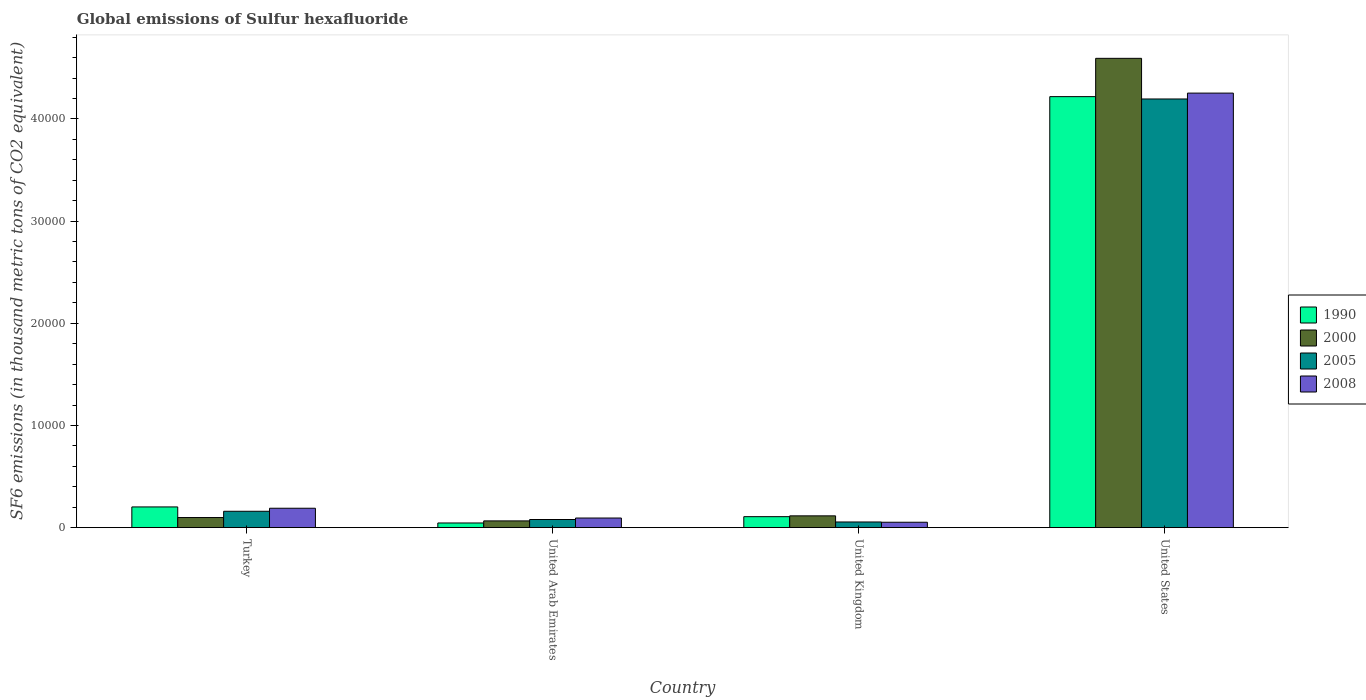How many different coloured bars are there?
Your response must be concise. 4. How many groups of bars are there?
Your answer should be compact. 4. Are the number of bars per tick equal to the number of legend labels?
Your response must be concise. Yes. How many bars are there on the 4th tick from the left?
Your answer should be very brief. 4. What is the label of the 1st group of bars from the left?
Provide a succinct answer. Turkey. What is the global emissions of Sulfur hexafluoride in 1990 in Turkey?
Make the answer very short. 2027.1. Across all countries, what is the maximum global emissions of Sulfur hexafluoride in 2000?
Your response must be concise. 4.59e+04. Across all countries, what is the minimum global emissions of Sulfur hexafluoride in 2008?
Offer a very short reply. 528.9. In which country was the global emissions of Sulfur hexafluoride in 2005 minimum?
Offer a very short reply. United Kingdom. What is the total global emissions of Sulfur hexafluoride in 2008 in the graph?
Offer a terse response. 4.59e+04. What is the difference between the global emissions of Sulfur hexafluoride in 2008 in Turkey and that in United Arab Emirates?
Offer a terse response. 957.4. What is the difference between the global emissions of Sulfur hexafluoride in 2005 in United Arab Emirates and the global emissions of Sulfur hexafluoride in 2008 in Turkey?
Your response must be concise. -1102.6. What is the average global emissions of Sulfur hexafluoride in 1990 per country?
Your answer should be very brief. 1.14e+04. What is the difference between the global emissions of Sulfur hexafluoride of/in 2008 and global emissions of Sulfur hexafluoride of/in 2000 in United States?
Offer a terse response. -3401.5. In how many countries, is the global emissions of Sulfur hexafluoride in 1990 greater than 4000 thousand metric tons?
Offer a terse response. 1. What is the ratio of the global emissions of Sulfur hexafluoride in 1990 in Turkey to that in United States?
Provide a succinct answer. 0.05. Is the global emissions of Sulfur hexafluoride in 2005 in Turkey less than that in United Kingdom?
Your response must be concise. No. What is the difference between the highest and the second highest global emissions of Sulfur hexafluoride in 2000?
Your answer should be compact. 4.49e+04. What is the difference between the highest and the lowest global emissions of Sulfur hexafluoride in 2005?
Offer a very short reply. 4.14e+04. In how many countries, is the global emissions of Sulfur hexafluoride in 1990 greater than the average global emissions of Sulfur hexafluoride in 1990 taken over all countries?
Provide a short and direct response. 1. What does the 4th bar from the left in Turkey represents?
Keep it short and to the point. 2008. What does the 2nd bar from the right in United States represents?
Make the answer very short. 2005. Is it the case that in every country, the sum of the global emissions of Sulfur hexafluoride in 2008 and global emissions of Sulfur hexafluoride in 2005 is greater than the global emissions of Sulfur hexafluoride in 1990?
Offer a terse response. Yes. Are all the bars in the graph horizontal?
Keep it short and to the point. No. How many countries are there in the graph?
Keep it short and to the point. 4. What is the difference between two consecutive major ticks on the Y-axis?
Provide a succinct answer. 10000. Does the graph contain any zero values?
Your answer should be compact. No. Does the graph contain grids?
Give a very brief answer. No. Where does the legend appear in the graph?
Offer a very short reply. Center right. What is the title of the graph?
Your answer should be very brief. Global emissions of Sulfur hexafluoride. What is the label or title of the X-axis?
Your response must be concise. Country. What is the label or title of the Y-axis?
Give a very brief answer. SF6 emissions (in thousand metric tons of CO2 equivalent). What is the SF6 emissions (in thousand metric tons of CO2 equivalent) of 1990 in Turkey?
Provide a succinct answer. 2027.1. What is the SF6 emissions (in thousand metric tons of CO2 equivalent) in 2000 in Turkey?
Your answer should be very brief. 989.2. What is the SF6 emissions (in thousand metric tons of CO2 equivalent) of 2005 in Turkey?
Keep it short and to the point. 1602.2. What is the SF6 emissions (in thousand metric tons of CO2 equivalent) of 2008 in Turkey?
Your answer should be very brief. 1898.8. What is the SF6 emissions (in thousand metric tons of CO2 equivalent) of 1990 in United Arab Emirates?
Provide a succinct answer. 456.1. What is the SF6 emissions (in thousand metric tons of CO2 equivalent) in 2000 in United Arab Emirates?
Offer a terse response. 660.1. What is the SF6 emissions (in thousand metric tons of CO2 equivalent) in 2005 in United Arab Emirates?
Keep it short and to the point. 796.2. What is the SF6 emissions (in thousand metric tons of CO2 equivalent) in 2008 in United Arab Emirates?
Provide a short and direct response. 941.4. What is the SF6 emissions (in thousand metric tons of CO2 equivalent) of 1990 in United Kingdom?
Your answer should be very brief. 1073.9. What is the SF6 emissions (in thousand metric tons of CO2 equivalent) in 2000 in United Kingdom?
Provide a short and direct response. 1154.1. What is the SF6 emissions (in thousand metric tons of CO2 equivalent) in 2005 in United Kingdom?
Make the answer very short. 554.2. What is the SF6 emissions (in thousand metric tons of CO2 equivalent) of 2008 in United Kingdom?
Give a very brief answer. 528.9. What is the SF6 emissions (in thousand metric tons of CO2 equivalent) of 1990 in United States?
Provide a succinct answer. 4.22e+04. What is the SF6 emissions (in thousand metric tons of CO2 equivalent) of 2000 in United States?
Your answer should be very brief. 4.59e+04. What is the SF6 emissions (in thousand metric tons of CO2 equivalent) of 2005 in United States?
Your answer should be compact. 4.20e+04. What is the SF6 emissions (in thousand metric tons of CO2 equivalent) in 2008 in United States?
Your response must be concise. 4.25e+04. Across all countries, what is the maximum SF6 emissions (in thousand metric tons of CO2 equivalent) in 1990?
Ensure brevity in your answer.  4.22e+04. Across all countries, what is the maximum SF6 emissions (in thousand metric tons of CO2 equivalent) of 2000?
Your answer should be very brief. 4.59e+04. Across all countries, what is the maximum SF6 emissions (in thousand metric tons of CO2 equivalent) of 2005?
Provide a succinct answer. 4.20e+04. Across all countries, what is the maximum SF6 emissions (in thousand metric tons of CO2 equivalent) of 2008?
Your response must be concise. 4.25e+04. Across all countries, what is the minimum SF6 emissions (in thousand metric tons of CO2 equivalent) of 1990?
Offer a very short reply. 456.1. Across all countries, what is the minimum SF6 emissions (in thousand metric tons of CO2 equivalent) of 2000?
Ensure brevity in your answer.  660.1. Across all countries, what is the minimum SF6 emissions (in thousand metric tons of CO2 equivalent) in 2005?
Offer a terse response. 554.2. Across all countries, what is the minimum SF6 emissions (in thousand metric tons of CO2 equivalent) of 2008?
Ensure brevity in your answer.  528.9. What is the total SF6 emissions (in thousand metric tons of CO2 equivalent) of 1990 in the graph?
Keep it short and to the point. 4.57e+04. What is the total SF6 emissions (in thousand metric tons of CO2 equivalent) of 2000 in the graph?
Keep it short and to the point. 4.87e+04. What is the total SF6 emissions (in thousand metric tons of CO2 equivalent) of 2005 in the graph?
Keep it short and to the point. 4.49e+04. What is the total SF6 emissions (in thousand metric tons of CO2 equivalent) in 2008 in the graph?
Ensure brevity in your answer.  4.59e+04. What is the difference between the SF6 emissions (in thousand metric tons of CO2 equivalent) in 1990 in Turkey and that in United Arab Emirates?
Provide a short and direct response. 1571. What is the difference between the SF6 emissions (in thousand metric tons of CO2 equivalent) in 2000 in Turkey and that in United Arab Emirates?
Provide a short and direct response. 329.1. What is the difference between the SF6 emissions (in thousand metric tons of CO2 equivalent) of 2005 in Turkey and that in United Arab Emirates?
Your answer should be very brief. 806. What is the difference between the SF6 emissions (in thousand metric tons of CO2 equivalent) of 2008 in Turkey and that in United Arab Emirates?
Ensure brevity in your answer.  957.4. What is the difference between the SF6 emissions (in thousand metric tons of CO2 equivalent) in 1990 in Turkey and that in United Kingdom?
Offer a terse response. 953.2. What is the difference between the SF6 emissions (in thousand metric tons of CO2 equivalent) in 2000 in Turkey and that in United Kingdom?
Offer a very short reply. -164.9. What is the difference between the SF6 emissions (in thousand metric tons of CO2 equivalent) of 2005 in Turkey and that in United Kingdom?
Provide a succinct answer. 1048. What is the difference between the SF6 emissions (in thousand metric tons of CO2 equivalent) in 2008 in Turkey and that in United Kingdom?
Keep it short and to the point. 1369.9. What is the difference between the SF6 emissions (in thousand metric tons of CO2 equivalent) in 1990 in Turkey and that in United States?
Provide a short and direct response. -4.02e+04. What is the difference between the SF6 emissions (in thousand metric tons of CO2 equivalent) of 2000 in Turkey and that in United States?
Keep it short and to the point. -4.49e+04. What is the difference between the SF6 emissions (in thousand metric tons of CO2 equivalent) in 2005 in Turkey and that in United States?
Make the answer very short. -4.04e+04. What is the difference between the SF6 emissions (in thousand metric tons of CO2 equivalent) in 2008 in Turkey and that in United States?
Your answer should be compact. -4.06e+04. What is the difference between the SF6 emissions (in thousand metric tons of CO2 equivalent) of 1990 in United Arab Emirates and that in United Kingdom?
Provide a succinct answer. -617.8. What is the difference between the SF6 emissions (in thousand metric tons of CO2 equivalent) of 2000 in United Arab Emirates and that in United Kingdom?
Provide a succinct answer. -494. What is the difference between the SF6 emissions (in thousand metric tons of CO2 equivalent) in 2005 in United Arab Emirates and that in United Kingdom?
Give a very brief answer. 242. What is the difference between the SF6 emissions (in thousand metric tons of CO2 equivalent) of 2008 in United Arab Emirates and that in United Kingdom?
Your answer should be very brief. 412.5. What is the difference between the SF6 emissions (in thousand metric tons of CO2 equivalent) of 1990 in United Arab Emirates and that in United States?
Give a very brief answer. -4.17e+04. What is the difference between the SF6 emissions (in thousand metric tons of CO2 equivalent) in 2000 in United Arab Emirates and that in United States?
Offer a terse response. -4.53e+04. What is the difference between the SF6 emissions (in thousand metric tons of CO2 equivalent) in 2005 in United Arab Emirates and that in United States?
Keep it short and to the point. -4.12e+04. What is the difference between the SF6 emissions (in thousand metric tons of CO2 equivalent) of 2008 in United Arab Emirates and that in United States?
Your answer should be very brief. -4.16e+04. What is the difference between the SF6 emissions (in thousand metric tons of CO2 equivalent) in 1990 in United Kingdom and that in United States?
Provide a succinct answer. -4.11e+04. What is the difference between the SF6 emissions (in thousand metric tons of CO2 equivalent) of 2000 in United Kingdom and that in United States?
Offer a terse response. -4.48e+04. What is the difference between the SF6 emissions (in thousand metric tons of CO2 equivalent) in 2005 in United Kingdom and that in United States?
Offer a terse response. -4.14e+04. What is the difference between the SF6 emissions (in thousand metric tons of CO2 equivalent) in 2008 in United Kingdom and that in United States?
Your response must be concise. -4.20e+04. What is the difference between the SF6 emissions (in thousand metric tons of CO2 equivalent) in 1990 in Turkey and the SF6 emissions (in thousand metric tons of CO2 equivalent) in 2000 in United Arab Emirates?
Make the answer very short. 1367. What is the difference between the SF6 emissions (in thousand metric tons of CO2 equivalent) of 1990 in Turkey and the SF6 emissions (in thousand metric tons of CO2 equivalent) of 2005 in United Arab Emirates?
Your response must be concise. 1230.9. What is the difference between the SF6 emissions (in thousand metric tons of CO2 equivalent) in 1990 in Turkey and the SF6 emissions (in thousand metric tons of CO2 equivalent) in 2008 in United Arab Emirates?
Your answer should be compact. 1085.7. What is the difference between the SF6 emissions (in thousand metric tons of CO2 equivalent) in 2000 in Turkey and the SF6 emissions (in thousand metric tons of CO2 equivalent) in 2005 in United Arab Emirates?
Your answer should be very brief. 193. What is the difference between the SF6 emissions (in thousand metric tons of CO2 equivalent) of 2000 in Turkey and the SF6 emissions (in thousand metric tons of CO2 equivalent) of 2008 in United Arab Emirates?
Your answer should be very brief. 47.8. What is the difference between the SF6 emissions (in thousand metric tons of CO2 equivalent) of 2005 in Turkey and the SF6 emissions (in thousand metric tons of CO2 equivalent) of 2008 in United Arab Emirates?
Provide a short and direct response. 660.8. What is the difference between the SF6 emissions (in thousand metric tons of CO2 equivalent) in 1990 in Turkey and the SF6 emissions (in thousand metric tons of CO2 equivalent) in 2000 in United Kingdom?
Offer a very short reply. 873. What is the difference between the SF6 emissions (in thousand metric tons of CO2 equivalent) of 1990 in Turkey and the SF6 emissions (in thousand metric tons of CO2 equivalent) of 2005 in United Kingdom?
Give a very brief answer. 1472.9. What is the difference between the SF6 emissions (in thousand metric tons of CO2 equivalent) of 1990 in Turkey and the SF6 emissions (in thousand metric tons of CO2 equivalent) of 2008 in United Kingdom?
Provide a succinct answer. 1498.2. What is the difference between the SF6 emissions (in thousand metric tons of CO2 equivalent) in 2000 in Turkey and the SF6 emissions (in thousand metric tons of CO2 equivalent) in 2005 in United Kingdom?
Your answer should be very brief. 435. What is the difference between the SF6 emissions (in thousand metric tons of CO2 equivalent) in 2000 in Turkey and the SF6 emissions (in thousand metric tons of CO2 equivalent) in 2008 in United Kingdom?
Provide a succinct answer. 460.3. What is the difference between the SF6 emissions (in thousand metric tons of CO2 equivalent) in 2005 in Turkey and the SF6 emissions (in thousand metric tons of CO2 equivalent) in 2008 in United Kingdom?
Make the answer very short. 1073.3. What is the difference between the SF6 emissions (in thousand metric tons of CO2 equivalent) of 1990 in Turkey and the SF6 emissions (in thousand metric tons of CO2 equivalent) of 2000 in United States?
Provide a succinct answer. -4.39e+04. What is the difference between the SF6 emissions (in thousand metric tons of CO2 equivalent) in 1990 in Turkey and the SF6 emissions (in thousand metric tons of CO2 equivalent) in 2005 in United States?
Give a very brief answer. -3.99e+04. What is the difference between the SF6 emissions (in thousand metric tons of CO2 equivalent) of 1990 in Turkey and the SF6 emissions (in thousand metric tons of CO2 equivalent) of 2008 in United States?
Your answer should be very brief. -4.05e+04. What is the difference between the SF6 emissions (in thousand metric tons of CO2 equivalent) of 2000 in Turkey and the SF6 emissions (in thousand metric tons of CO2 equivalent) of 2005 in United States?
Your response must be concise. -4.10e+04. What is the difference between the SF6 emissions (in thousand metric tons of CO2 equivalent) in 2000 in Turkey and the SF6 emissions (in thousand metric tons of CO2 equivalent) in 2008 in United States?
Your answer should be very brief. -4.15e+04. What is the difference between the SF6 emissions (in thousand metric tons of CO2 equivalent) of 2005 in Turkey and the SF6 emissions (in thousand metric tons of CO2 equivalent) of 2008 in United States?
Provide a succinct answer. -4.09e+04. What is the difference between the SF6 emissions (in thousand metric tons of CO2 equivalent) in 1990 in United Arab Emirates and the SF6 emissions (in thousand metric tons of CO2 equivalent) in 2000 in United Kingdom?
Keep it short and to the point. -698. What is the difference between the SF6 emissions (in thousand metric tons of CO2 equivalent) in 1990 in United Arab Emirates and the SF6 emissions (in thousand metric tons of CO2 equivalent) in 2005 in United Kingdom?
Make the answer very short. -98.1. What is the difference between the SF6 emissions (in thousand metric tons of CO2 equivalent) of 1990 in United Arab Emirates and the SF6 emissions (in thousand metric tons of CO2 equivalent) of 2008 in United Kingdom?
Your answer should be compact. -72.8. What is the difference between the SF6 emissions (in thousand metric tons of CO2 equivalent) of 2000 in United Arab Emirates and the SF6 emissions (in thousand metric tons of CO2 equivalent) of 2005 in United Kingdom?
Keep it short and to the point. 105.9. What is the difference between the SF6 emissions (in thousand metric tons of CO2 equivalent) in 2000 in United Arab Emirates and the SF6 emissions (in thousand metric tons of CO2 equivalent) in 2008 in United Kingdom?
Offer a very short reply. 131.2. What is the difference between the SF6 emissions (in thousand metric tons of CO2 equivalent) in 2005 in United Arab Emirates and the SF6 emissions (in thousand metric tons of CO2 equivalent) in 2008 in United Kingdom?
Offer a terse response. 267.3. What is the difference between the SF6 emissions (in thousand metric tons of CO2 equivalent) in 1990 in United Arab Emirates and the SF6 emissions (in thousand metric tons of CO2 equivalent) in 2000 in United States?
Ensure brevity in your answer.  -4.55e+04. What is the difference between the SF6 emissions (in thousand metric tons of CO2 equivalent) in 1990 in United Arab Emirates and the SF6 emissions (in thousand metric tons of CO2 equivalent) in 2005 in United States?
Your answer should be compact. -4.15e+04. What is the difference between the SF6 emissions (in thousand metric tons of CO2 equivalent) of 1990 in United Arab Emirates and the SF6 emissions (in thousand metric tons of CO2 equivalent) of 2008 in United States?
Give a very brief answer. -4.21e+04. What is the difference between the SF6 emissions (in thousand metric tons of CO2 equivalent) in 2000 in United Arab Emirates and the SF6 emissions (in thousand metric tons of CO2 equivalent) in 2005 in United States?
Offer a terse response. -4.13e+04. What is the difference between the SF6 emissions (in thousand metric tons of CO2 equivalent) in 2000 in United Arab Emirates and the SF6 emissions (in thousand metric tons of CO2 equivalent) in 2008 in United States?
Your response must be concise. -4.19e+04. What is the difference between the SF6 emissions (in thousand metric tons of CO2 equivalent) of 2005 in United Arab Emirates and the SF6 emissions (in thousand metric tons of CO2 equivalent) of 2008 in United States?
Ensure brevity in your answer.  -4.17e+04. What is the difference between the SF6 emissions (in thousand metric tons of CO2 equivalent) of 1990 in United Kingdom and the SF6 emissions (in thousand metric tons of CO2 equivalent) of 2000 in United States?
Keep it short and to the point. -4.49e+04. What is the difference between the SF6 emissions (in thousand metric tons of CO2 equivalent) of 1990 in United Kingdom and the SF6 emissions (in thousand metric tons of CO2 equivalent) of 2005 in United States?
Your response must be concise. -4.09e+04. What is the difference between the SF6 emissions (in thousand metric tons of CO2 equivalent) in 1990 in United Kingdom and the SF6 emissions (in thousand metric tons of CO2 equivalent) in 2008 in United States?
Give a very brief answer. -4.15e+04. What is the difference between the SF6 emissions (in thousand metric tons of CO2 equivalent) in 2000 in United Kingdom and the SF6 emissions (in thousand metric tons of CO2 equivalent) in 2005 in United States?
Make the answer very short. -4.08e+04. What is the difference between the SF6 emissions (in thousand metric tons of CO2 equivalent) in 2000 in United Kingdom and the SF6 emissions (in thousand metric tons of CO2 equivalent) in 2008 in United States?
Make the answer very short. -4.14e+04. What is the difference between the SF6 emissions (in thousand metric tons of CO2 equivalent) in 2005 in United Kingdom and the SF6 emissions (in thousand metric tons of CO2 equivalent) in 2008 in United States?
Offer a very short reply. -4.20e+04. What is the average SF6 emissions (in thousand metric tons of CO2 equivalent) of 1990 per country?
Provide a short and direct response. 1.14e+04. What is the average SF6 emissions (in thousand metric tons of CO2 equivalent) in 2000 per country?
Keep it short and to the point. 1.22e+04. What is the average SF6 emissions (in thousand metric tons of CO2 equivalent) in 2005 per country?
Your answer should be very brief. 1.12e+04. What is the average SF6 emissions (in thousand metric tons of CO2 equivalent) of 2008 per country?
Your answer should be very brief. 1.15e+04. What is the difference between the SF6 emissions (in thousand metric tons of CO2 equivalent) in 1990 and SF6 emissions (in thousand metric tons of CO2 equivalent) in 2000 in Turkey?
Keep it short and to the point. 1037.9. What is the difference between the SF6 emissions (in thousand metric tons of CO2 equivalent) in 1990 and SF6 emissions (in thousand metric tons of CO2 equivalent) in 2005 in Turkey?
Offer a very short reply. 424.9. What is the difference between the SF6 emissions (in thousand metric tons of CO2 equivalent) in 1990 and SF6 emissions (in thousand metric tons of CO2 equivalent) in 2008 in Turkey?
Your answer should be very brief. 128.3. What is the difference between the SF6 emissions (in thousand metric tons of CO2 equivalent) of 2000 and SF6 emissions (in thousand metric tons of CO2 equivalent) of 2005 in Turkey?
Offer a very short reply. -613. What is the difference between the SF6 emissions (in thousand metric tons of CO2 equivalent) of 2000 and SF6 emissions (in thousand metric tons of CO2 equivalent) of 2008 in Turkey?
Provide a succinct answer. -909.6. What is the difference between the SF6 emissions (in thousand metric tons of CO2 equivalent) of 2005 and SF6 emissions (in thousand metric tons of CO2 equivalent) of 2008 in Turkey?
Your answer should be very brief. -296.6. What is the difference between the SF6 emissions (in thousand metric tons of CO2 equivalent) in 1990 and SF6 emissions (in thousand metric tons of CO2 equivalent) in 2000 in United Arab Emirates?
Provide a short and direct response. -204. What is the difference between the SF6 emissions (in thousand metric tons of CO2 equivalent) in 1990 and SF6 emissions (in thousand metric tons of CO2 equivalent) in 2005 in United Arab Emirates?
Provide a succinct answer. -340.1. What is the difference between the SF6 emissions (in thousand metric tons of CO2 equivalent) of 1990 and SF6 emissions (in thousand metric tons of CO2 equivalent) of 2008 in United Arab Emirates?
Your answer should be very brief. -485.3. What is the difference between the SF6 emissions (in thousand metric tons of CO2 equivalent) in 2000 and SF6 emissions (in thousand metric tons of CO2 equivalent) in 2005 in United Arab Emirates?
Give a very brief answer. -136.1. What is the difference between the SF6 emissions (in thousand metric tons of CO2 equivalent) in 2000 and SF6 emissions (in thousand metric tons of CO2 equivalent) in 2008 in United Arab Emirates?
Your answer should be very brief. -281.3. What is the difference between the SF6 emissions (in thousand metric tons of CO2 equivalent) of 2005 and SF6 emissions (in thousand metric tons of CO2 equivalent) of 2008 in United Arab Emirates?
Give a very brief answer. -145.2. What is the difference between the SF6 emissions (in thousand metric tons of CO2 equivalent) of 1990 and SF6 emissions (in thousand metric tons of CO2 equivalent) of 2000 in United Kingdom?
Your response must be concise. -80.2. What is the difference between the SF6 emissions (in thousand metric tons of CO2 equivalent) in 1990 and SF6 emissions (in thousand metric tons of CO2 equivalent) in 2005 in United Kingdom?
Your response must be concise. 519.7. What is the difference between the SF6 emissions (in thousand metric tons of CO2 equivalent) of 1990 and SF6 emissions (in thousand metric tons of CO2 equivalent) of 2008 in United Kingdom?
Give a very brief answer. 545. What is the difference between the SF6 emissions (in thousand metric tons of CO2 equivalent) of 2000 and SF6 emissions (in thousand metric tons of CO2 equivalent) of 2005 in United Kingdom?
Ensure brevity in your answer.  599.9. What is the difference between the SF6 emissions (in thousand metric tons of CO2 equivalent) of 2000 and SF6 emissions (in thousand metric tons of CO2 equivalent) of 2008 in United Kingdom?
Offer a very short reply. 625.2. What is the difference between the SF6 emissions (in thousand metric tons of CO2 equivalent) of 2005 and SF6 emissions (in thousand metric tons of CO2 equivalent) of 2008 in United Kingdom?
Your answer should be compact. 25.3. What is the difference between the SF6 emissions (in thousand metric tons of CO2 equivalent) in 1990 and SF6 emissions (in thousand metric tons of CO2 equivalent) in 2000 in United States?
Your answer should be very brief. -3747.6. What is the difference between the SF6 emissions (in thousand metric tons of CO2 equivalent) in 1990 and SF6 emissions (in thousand metric tons of CO2 equivalent) in 2005 in United States?
Offer a terse response. 229.6. What is the difference between the SF6 emissions (in thousand metric tons of CO2 equivalent) in 1990 and SF6 emissions (in thousand metric tons of CO2 equivalent) in 2008 in United States?
Provide a succinct answer. -346.1. What is the difference between the SF6 emissions (in thousand metric tons of CO2 equivalent) in 2000 and SF6 emissions (in thousand metric tons of CO2 equivalent) in 2005 in United States?
Your answer should be very brief. 3977.2. What is the difference between the SF6 emissions (in thousand metric tons of CO2 equivalent) of 2000 and SF6 emissions (in thousand metric tons of CO2 equivalent) of 2008 in United States?
Provide a short and direct response. 3401.5. What is the difference between the SF6 emissions (in thousand metric tons of CO2 equivalent) in 2005 and SF6 emissions (in thousand metric tons of CO2 equivalent) in 2008 in United States?
Give a very brief answer. -575.7. What is the ratio of the SF6 emissions (in thousand metric tons of CO2 equivalent) of 1990 in Turkey to that in United Arab Emirates?
Provide a succinct answer. 4.44. What is the ratio of the SF6 emissions (in thousand metric tons of CO2 equivalent) in 2000 in Turkey to that in United Arab Emirates?
Your response must be concise. 1.5. What is the ratio of the SF6 emissions (in thousand metric tons of CO2 equivalent) of 2005 in Turkey to that in United Arab Emirates?
Offer a very short reply. 2.01. What is the ratio of the SF6 emissions (in thousand metric tons of CO2 equivalent) of 2008 in Turkey to that in United Arab Emirates?
Make the answer very short. 2.02. What is the ratio of the SF6 emissions (in thousand metric tons of CO2 equivalent) of 1990 in Turkey to that in United Kingdom?
Your response must be concise. 1.89. What is the ratio of the SF6 emissions (in thousand metric tons of CO2 equivalent) of 2005 in Turkey to that in United Kingdom?
Give a very brief answer. 2.89. What is the ratio of the SF6 emissions (in thousand metric tons of CO2 equivalent) of 2008 in Turkey to that in United Kingdom?
Keep it short and to the point. 3.59. What is the ratio of the SF6 emissions (in thousand metric tons of CO2 equivalent) in 1990 in Turkey to that in United States?
Keep it short and to the point. 0.05. What is the ratio of the SF6 emissions (in thousand metric tons of CO2 equivalent) of 2000 in Turkey to that in United States?
Keep it short and to the point. 0.02. What is the ratio of the SF6 emissions (in thousand metric tons of CO2 equivalent) of 2005 in Turkey to that in United States?
Make the answer very short. 0.04. What is the ratio of the SF6 emissions (in thousand metric tons of CO2 equivalent) in 2008 in Turkey to that in United States?
Offer a very short reply. 0.04. What is the ratio of the SF6 emissions (in thousand metric tons of CO2 equivalent) in 1990 in United Arab Emirates to that in United Kingdom?
Make the answer very short. 0.42. What is the ratio of the SF6 emissions (in thousand metric tons of CO2 equivalent) in 2000 in United Arab Emirates to that in United Kingdom?
Keep it short and to the point. 0.57. What is the ratio of the SF6 emissions (in thousand metric tons of CO2 equivalent) of 2005 in United Arab Emirates to that in United Kingdom?
Your answer should be compact. 1.44. What is the ratio of the SF6 emissions (in thousand metric tons of CO2 equivalent) of 2008 in United Arab Emirates to that in United Kingdom?
Offer a terse response. 1.78. What is the ratio of the SF6 emissions (in thousand metric tons of CO2 equivalent) in 1990 in United Arab Emirates to that in United States?
Your answer should be very brief. 0.01. What is the ratio of the SF6 emissions (in thousand metric tons of CO2 equivalent) in 2000 in United Arab Emirates to that in United States?
Ensure brevity in your answer.  0.01. What is the ratio of the SF6 emissions (in thousand metric tons of CO2 equivalent) in 2005 in United Arab Emirates to that in United States?
Give a very brief answer. 0.02. What is the ratio of the SF6 emissions (in thousand metric tons of CO2 equivalent) of 2008 in United Arab Emirates to that in United States?
Offer a very short reply. 0.02. What is the ratio of the SF6 emissions (in thousand metric tons of CO2 equivalent) of 1990 in United Kingdom to that in United States?
Make the answer very short. 0.03. What is the ratio of the SF6 emissions (in thousand metric tons of CO2 equivalent) in 2000 in United Kingdom to that in United States?
Offer a terse response. 0.03. What is the ratio of the SF6 emissions (in thousand metric tons of CO2 equivalent) of 2005 in United Kingdom to that in United States?
Ensure brevity in your answer.  0.01. What is the ratio of the SF6 emissions (in thousand metric tons of CO2 equivalent) of 2008 in United Kingdom to that in United States?
Ensure brevity in your answer.  0.01. What is the difference between the highest and the second highest SF6 emissions (in thousand metric tons of CO2 equivalent) of 1990?
Your answer should be very brief. 4.02e+04. What is the difference between the highest and the second highest SF6 emissions (in thousand metric tons of CO2 equivalent) of 2000?
Ensure brevity in your answer.  4.48e+04. What is the difference between the highest and the second highest SF6 emissions (in thousand metric tons of CO2 equivalent) in 2005?
Make the answer very short. 4.04e+04. What is the difference between the highest and the second highest SF6 emissions (in thousand metric tons of CO2 equivalent) of 2008?
Ensure brevity in your answer.  4.06e+04. What is the difference between the highest and the lowest SF6 emissions (in thousand metric tons of CO2 equivalent) of 1990?
Your answer should be very brief. 4.17e+04. What is the difference between the highest and the lowest SF6 emissions (in thousand metric tons of CO2 equivalent) in 2000?
Ensure brevity in your answer.  4.53e+04. What is the difference between the highest and the lowest SF6 emissions (in thousand metric tons of CO2 equivalent) in 2005?
Offer a very short reply. 4.14e+04. What is the difference between the highest and the lowest SF6 emissions (in thousand metric tons of CO2 equivalent) in 2008?
Provide a succinct answer. 4.20e+04. 